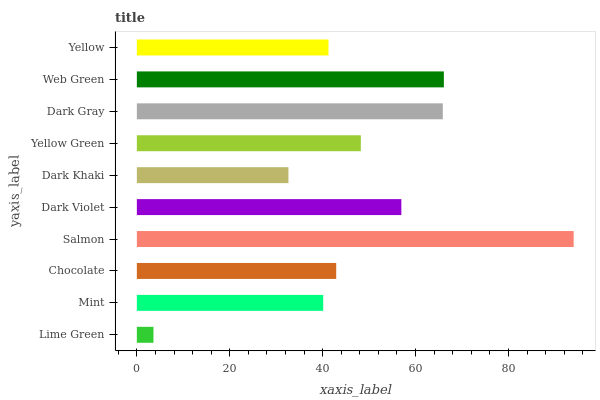Is Lime Green the minimum?
Answer yes or no. Yes. Is Salmon the maximum?
Answer yes or no. Yes. Is Mint the minimum?
Answer yes or no. No. Is Mint the maximum?
Answer yes or no. No. Is Mint greater than Lime Green?
Answer yes or no. Yes. Is Lime Green less than Mint?
Answer yes or no. Yes. Is Lime Green greater than Mint?
Answer yes or no. No. Is Mint less than Lime Green?
Answer yes or no. No. Is Yellow Green the high median?
Answer yes or no. Yes. Is Chocolate the low median?
Answer yes or no. Yes. Is Dark Gray the high median?
Answer yes or no. No. Is Lime Green the low median?
Answer yes or no. No. 